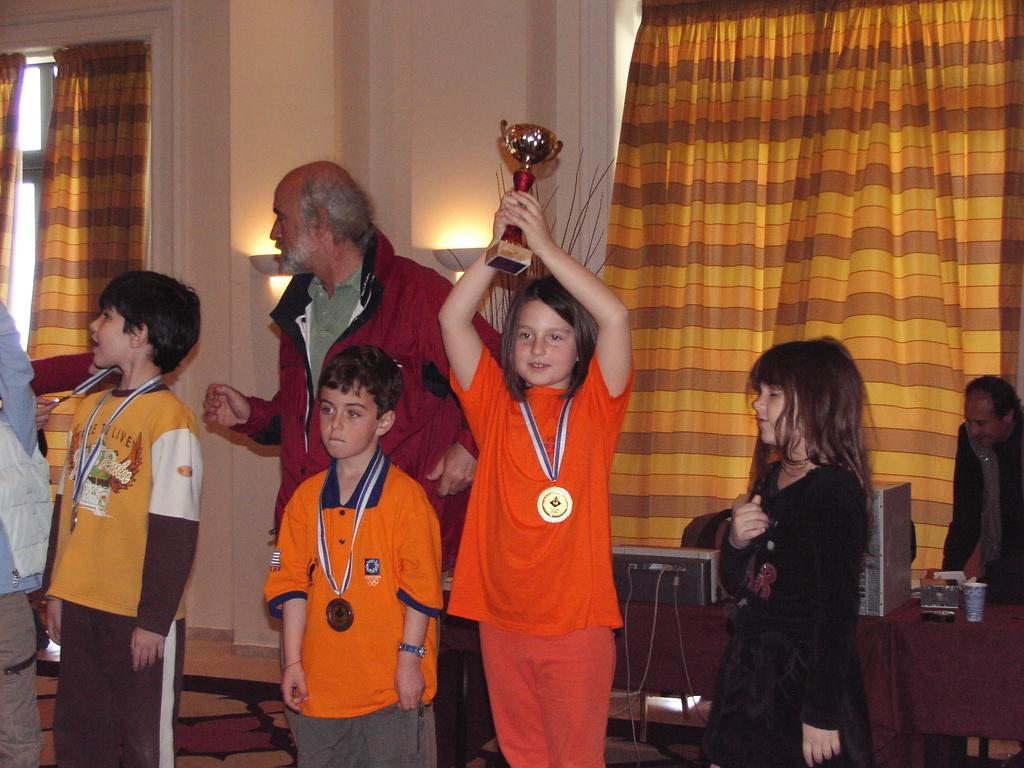How many children are in the image? There are 3 children in the image. What are the children wearing? The children are wearing medals. What is the girl holding? The girl is holding a trophy. Can you describe the background of the image? There are other people, a table, windows, and curtains associated with the windows in the background. What type of wilderness can be seen through the windows in the image? There is no wilderness visible through the windows in the image; only curtains are associated with the windows. What time is indicated by the clock in the image? There is no clock present in the image. 